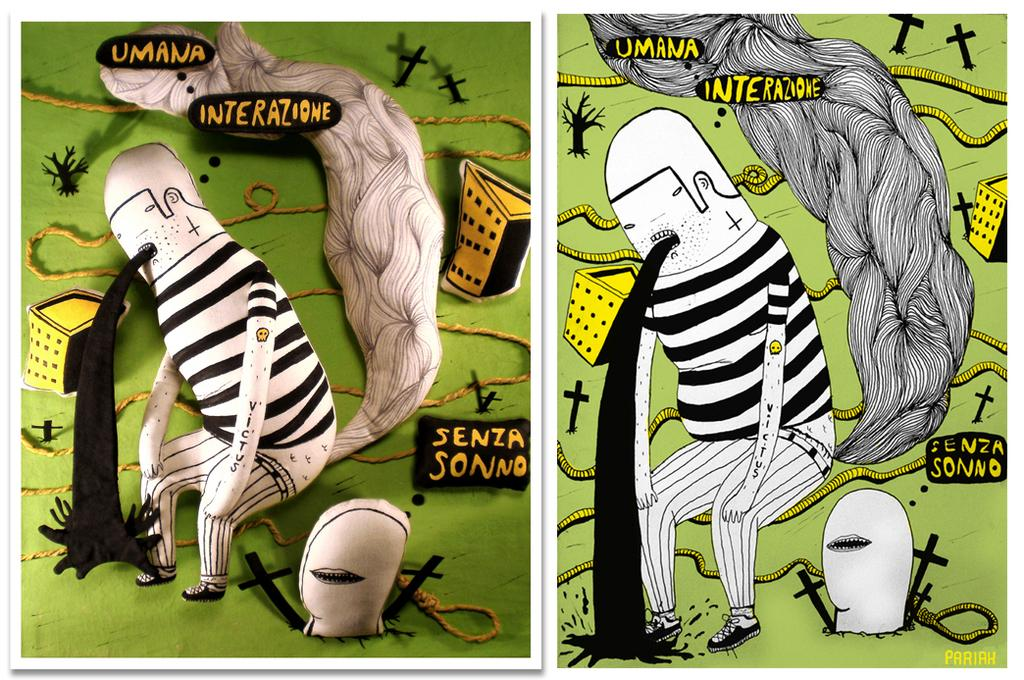What type of artwork is the image? The image is a collage. What type of characters can be seen in the image? There are cartoons in the image. What type of structures are depicted in the image? There are buildings in the image. What type of objects are present in the image? There are ropes in the image. What type of written content is present in the image? There is text in the image. What type of non-textual symbols are present in the image? There are symbols in the image. What type of flowers are present in the image? There are no flowers present in the image. What type of throne can be seen in the image? There is no throne present in the image. 